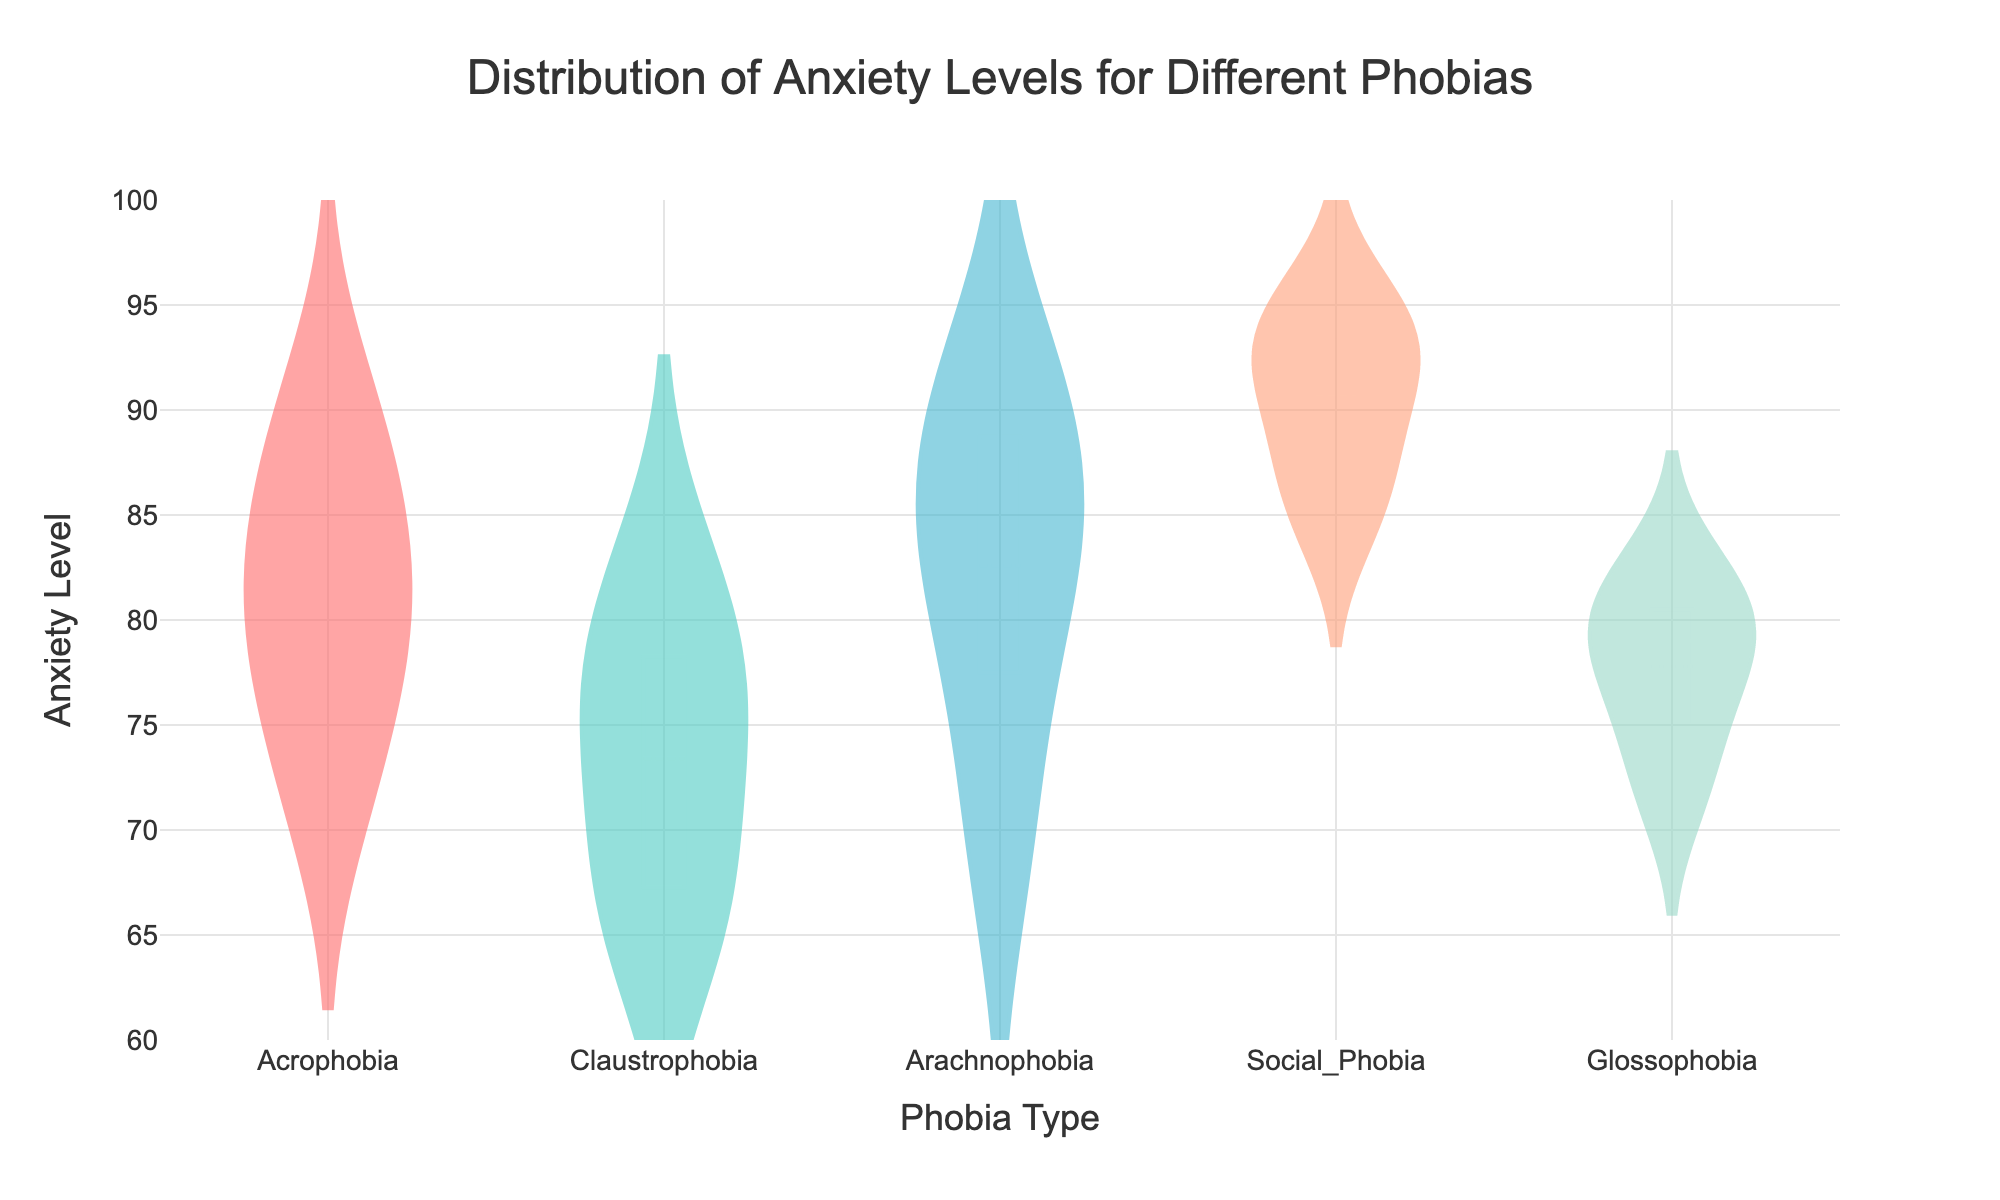What is the title of the plot? The title is the text placed at the top center of the plot, describing the main topic of the visualization. In this case, it reads "Distribution of Anxiety Levels for Different Phobias".
Answer: Distribution of Anxiety Levels for Different Phobias What phobia types are included in the plot? The plot shows the distribution of anxiety levels for five different phobia types. These types are evident from the labels on the x-axis and the legend on the plot.
Answer: Acrophobia, Claustrophobia, Arachnophobia, Social_Phobia, Glossophobia Which phobia type shows the highest mean anxiety level? Locate the meanline (indicated by a distinct line) within each violin plot. The highest meanline appears in the violin plot for Social_Phobia. This suggests Social_Phobia has the highest mean anxiety level.
Answer: Social_Phobia What is the range of anxiety levels for Claustrophobia? Identify the violin plot for Claustrophobia and observe the range it covers along the y-axis. The range of anxiety levels for Claustrophobia appears to be from approximately 65 to 82.
Answer: 65 to 82 Which phobia has the lowest reported anxiety level? The lowest point on the y-axis within any of the violin plots represents the lowest anxiety level. The lowest point appears in the violin plot for Claustrophobia, around 65.
Answer: Claustrophobia Compare the variability in anxiety levels between Acrophobia and Arachnophobia. Which one shows more variability? Compare the spread of the violin plots for Acrophobia and Arachnophobia along the y-axis. Acrophobia shows a wider spread from about 72 to 90 compared to Arachnophobia's spread from about 70 to 91, suggesting that Acrophobia displays more variability.
Answer: Acrophobia What is the median anxiety level for Glossophobia? Locate the box plot within the violin plot for Glossophobia. The line within the box represents the median. This line appears around the 79 mark on the y-axis.
Answer: 79 Between Social_Phobia and Acrophobia, which has a larger interquartile range (IQR)? The IQR is represented by the width of the box in the box plot within each violin plot. Comparing Social_Phobia and Acrophobia, the box for Social_Phobia appears wider, indicating a larger IQR.
Answer: Social_Phobia How does the range of anxiety levels in Arachnophobia compare to that in Glossophobia? Compare the vertical span of the violin plots for both phobias. Arachnophobia spans from approximately 70 to 91, while Glossophobia spans from around 72 to 82, indicating that Arachnophobia has a wider range.
Answer: Arachnophobia has a wider range What can you infer about the consistency of anxiety levels in Social_Phobia compared to Claustrophobia? Comparing the violin plots, Social_Phobia has a more concentrated distribution around higher levels, whereas Claustrophobia shows a more even spread. This suggests that anxiety levels in Social_Phobia are more consistently high, while Claustrophobia exhibits more variability or inconsistency.
Answer: Social_Phobia has more consistent anxiety levels 